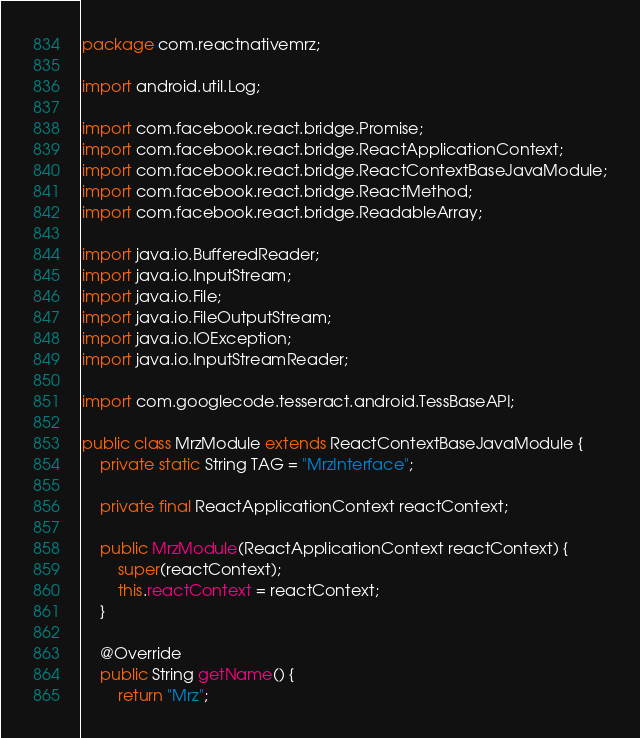<code> <loc_0><loc_0><loc_500><loc_500><_Java_>package com.reactnativemrz;

import android.util.Log;

import com.facebook.react.bridge.Promise;
import com.facebook.react.bridge.ReactApplicationContext;
import com.facebook.react.bridge.ReactContextBaseJavaModule;
import com.facebook.react.bridge.ReactMethod;
import com.facebook.react.bridge.ReadableArray;

import java.io.BufferedReader;
import java.io.InputStream;
import java.io.File;
import java.io.FileOutputStream;
import java.io.IOException;
import java.io.InputStreamReader;

import com.googlecode.tesseract.android.TessBaseAPI;

public class MrzModule extends ReactContextBaseJavaModule {
    private static String TAG = "MrzInterface";

    private final ReactApplicationContext reactContext;

    public MrzModule(ReactApplicationContext reactContext) {
        super(reactContext);
        this.reactContext = reactContext;
    }

    @Override
    public String getName() {
        return "Mrz";</code> 